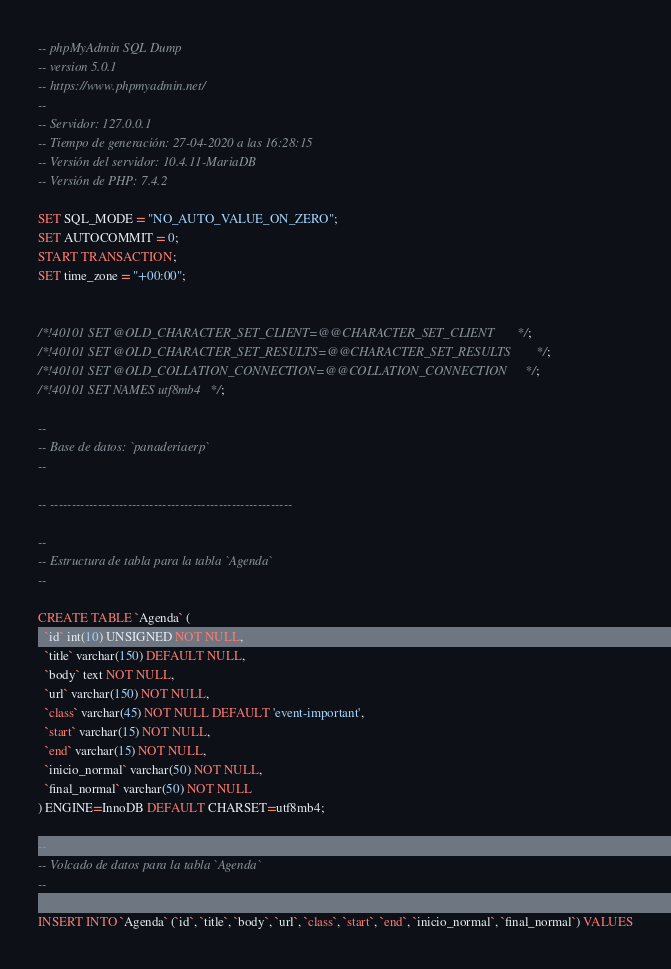Convert code to text. <code><loc_0><loc_0><loc_500><loc_500><_SQL_>-- phpMyAdmin SQL Dump
-- version 5.0.1
-- https://www.phpmyadmin.net/
--
-- Servidor: 127.0.0.1
-- Tiempo de generación: 27-04-2020 a las 16:28:15
-- Versión del servidor: 10.4.11-MariaDB
-- Versión de PHP: 7.4.2

SET SQL_MODE = "NO_AUTO_VALUE_ON_ZERO";
SET AUTOCOMMIT = 0;
START TRANSACTION;
SET time_zone = "+00:00";


/*!40101 SET @OLD_CHARACTER_SET_CLIENT=@@CHARACTER_SET_CLIENT */;
/*!40101 SET @OLD_CHARACTER_SET_RESULTS=@@CHARACTER_SET_RESULTS */;
/*!40101 SET @OLD_COLLATION_CONNECTION=@@COLLATION_CONNECTION */;
/*!40101 SET NAMES utf8mb4 */;

--
-- Base de datos: `panaderiaerp`
--

-- --------------------------------------------------------

--
-- Estructura de tabla para la tabla `Agenda`
--

CREATE TABLE `Agenda` (
  `id` int(10) UNSIGNED NOT NULL,
  `title` varchar(150) DEFAULT NULL,
  `body` text NOT NULL,
  `url` varchar(150) NOT NULL,
  `class` varchar(45) NOT NULL DEFAULT 'event-important',
  `start` varchar(15) NOT NULL,
  `end` varchar(15) NOT NULL,
  `inicio_normal` varchar(50) NOT NULL,
  `final_normal` varchar(50) NOT NULL
) ENGINE=InnoDB DEFAULT CHARSET=utf8mb4;

--
-- Volcado de datos para la tabla `Agenda`
--

INSERT INTO `Agenda` (`id`, `title`, `body`, `url`, `class`, `start`, `end`, `inicio_normal`, `final_normal`) VALUES</code> 